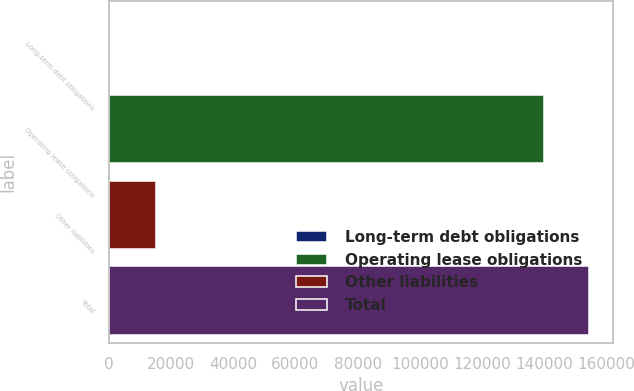Convert chart to OTSL. <chart><loc_0><loc_0><loc_500><loc_500><bar_chart><fcel>Long-term debt obligations<fcel>Operating lease obligations<fcel>Other liabilities<fcel>Total<nl><fcel>505<fcel>139740<fcel>15153.5<fcel>154388<nl></chart> 